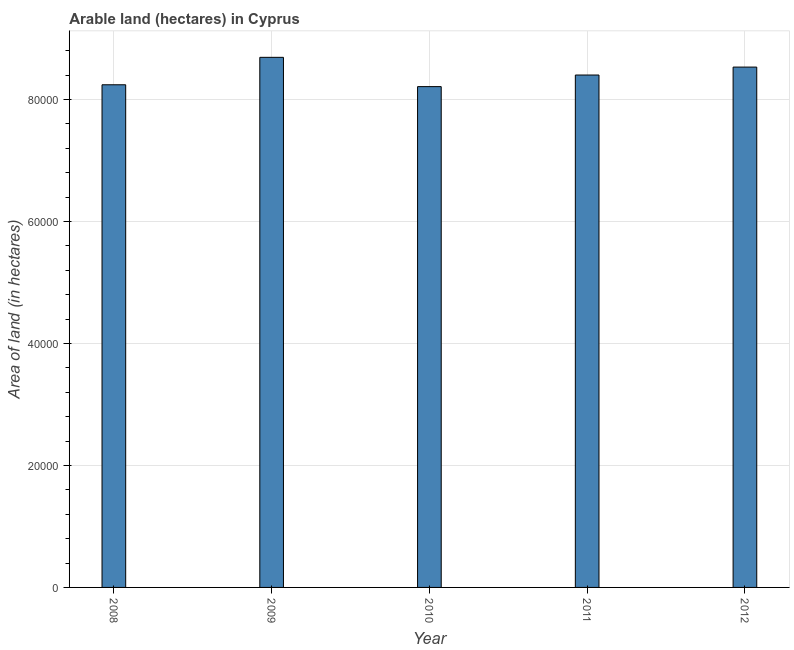Does the graph contain grids?
Provide a succinct answer. Yes. What is the title of the graph?
Offer a very short reply. Arable land (hectares) in Cyprus. What is the label or title of the Y-axis?
Ensure brevity in your answer.  Area of land (in hectares). What is the area of land in 2011?
Give a very brief answer. 8.40e+04. Across all years, what is the maximum area of land?
Provide a short and direct response. 8.69e+04. Across all years, what is the minimum area of land?
Provide a succinct answer. 8.21e+04. In which year was the area of land maximum?
Your answer should be very brief. 2009. What is the sum of the area of land?
Offer a very short reply. 4.21e+05. What is the difference between the area of land in 2011 and 2012?
Provide a succinct answer. -1300. What is the average area of land per year?
Your answer should be very brief. 8.41e+04. What is the median area of land?
Your answer should be very brief. 8.40e+04. What is the ratio of the area of land in 2008 to that in 2012?
Provide a succinct answer. 0.97. Is the area of land in 2008 less than that in 2009?
Ensure brevity in your answer.  Yes. Is the difference between the area of land in 2008 and 2012 greater than the difference between any two years?
Provide a short and direct response. No. What is the difference between the highest and the second highest area of land?
Offer a terse response. 1600. Is the sum of the area of land in 2011 and 2012 greater than the maximum area of land across all years?
Your response must be concise. Yes. What is the difference between the highest and the lowest area of land?
Provide a short and direct response. 4800. In how many years, is the area of land greater than the average area of land taken over all years?
Your answer should be compact. 2. How many years are there in the graph?
Your answer should be compact. 5. What is the difference between two consecutive major ticks on the Y-axis?
Your response must be concise. 2.00e+04. What is the Area of land (in hectares) in 2008?
Give a very brief answer. 8.24e+04. What is the Area of land (in hectares) in 2009?
Ensure brevity in your answer.  8.69e+04. What is the Area of land (in hectares) in 2010?
Your answer should be very brief. 8.21e+04. What is the Area of land (in hectares) of 2011?
Ensure brevity in your answer.  8.40e+04. What is the Area of land (in hectares) of 2012?
Your response must be concise. 8.53e+04. What is the difference between the Area of land (in hectares) in 2008 and 2009?
Your response must be concise. -4500. What is the difference between the Area of land (in hectares) in 2008 and 2010?
Provide a succinct answer. 300. What is the difference between the Area of land (in hectares) in 2008 and 2011?
Provide a succinct answer. -1600. What is the difference between the Area of land (in hectares) in 2008 and 2012?
Your answer should be compact. -2900. What is the difference between the Area of land (in hectares) in 2009 and 2010?
Give a very brief answer. 4800. What is the difference between the Area of land (in hectares) in 2009 and 2011?
Offer a terse response. 2900. What is the difference between the Area of land (in hectares) in 2009 and 2012?
Make the answer very short. 1600. What is the difference between the Area of land (in hectares) in 2010 and 2011?
Ensure brevity in your answer.  -1900. What is the difference between the Area of land (in hectares) in 2010 and 2012?
Make the answer very short. -3200. What is the difference between the Area of land (in hectares) in 2011 and 2012?
Offer a terse response. -1300. What is the ratio of the Area of land (in hectares) in 2008 to that in 2009?
Your answer should be compact. 0.95. What is the ratio of the Area of land (in hectares) in 2008 to that in 2012?
Offer a terse response. 0.97. What is the ratio of the Area of land (in hectares) in 2009 to that in 2010?
Your response must be concise. 1.06. What is the ratio of the Area of land (in hectares) in 2009 to that in 2011?
Ensure brevity in your answer.  1.03. What is the ratio of the Area of land (in hectares) in 2010 to that in 2012?
Ensure brevity in your answer.  0.96. What is the ratio of the Area of land (in hectares) in 2011 to that in 2012?
Make the answer very short. 0.98. 